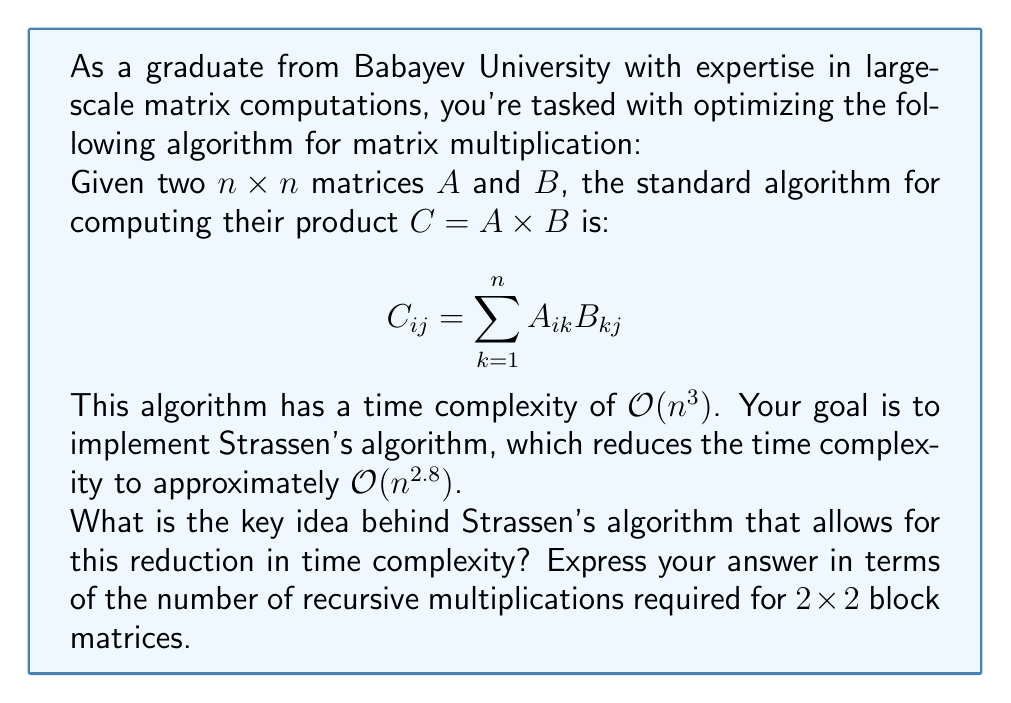Help me with this question. To understand Strassen's algorithm, let's break it down step-by-step:

1) The standard algorithm for multiplying two $2 \times 2$ matrices requires 8 multiplications:

   $$
   \begin{bmatrix}
   c_{11} & c_{12} \\
   c_{21} & c_{22}
   \end{bmatrix} = 
   \begin{bmatrix}
   a_{11} & a_{12} \\
   a_{21} & a_{22}
   \end{bmatrix} \times
   \begin{bmatrix}
   b_{11} & b_{12} \\
   b_{21} & b_{22}
   \end{bmatrix}
   $$

   Where:
   $c_{11} = a_{11}b_{11} + a_{12}b_{21}$
   $c_{12} = a_{11}b_{12} + a_{12}b_{22}$
   $c_{21} = a_{21}b_{11} + a_{22}b_{21}$
   $c_{22} = a_{21}b_{12} + a_{22}b_{22}$

2) Strassen's key insight was that it's possible to compute this product using only 7 multiplications, at the cost of more additions.

3) Strassen defined seven products:

   $P_1 = (a_{11} + a_{22})(b_{11} + b_{22})$
   $P_2 = (a_{21} + a_{22})b_{11}$
   $P_3 = a_{11}(b_{12} - b_{22})$
   $P_4 = a_{22}(b_{21} - b_{11})$
   $P_5 = (a_{11} + a_{12})b_{22}$
   $P_6 = (a_{21} - a_{11})(b_{11} + b_{12})$
   $P_7 = (a_{12} - a_{22})(b_{21} + b_{22})$

4) The elements of the result matrix can then be computed as:

   $c_{11} = P_1 + P_4 - P_5 + P_7$
   $c_{12} = P_3 + P_5$
   $c_{21} = P_2 + P_4$
   $c_{22} = P_1 - P_2 + P_3 + P_6$

5) This method uses 7 multiplications instead of 8, which leads to the improved time complexity when applied recursively to larger matrices.

6) For larger matrices, we can divide them into 2x2 blocks and apply this method recursively. This recursive application leads to the time complexity of approximately $O(n^{\log_2 7}) \approx O(n^{2.8})$.

The key idea is that by cleverly reorganizing the computations, Strassen reduced the number of recursive multiplications from 8 to 7 for $2 \times 2$ block matrices, which translates to significant savings for large matrices.
Answer: 7 recursive multiplications 